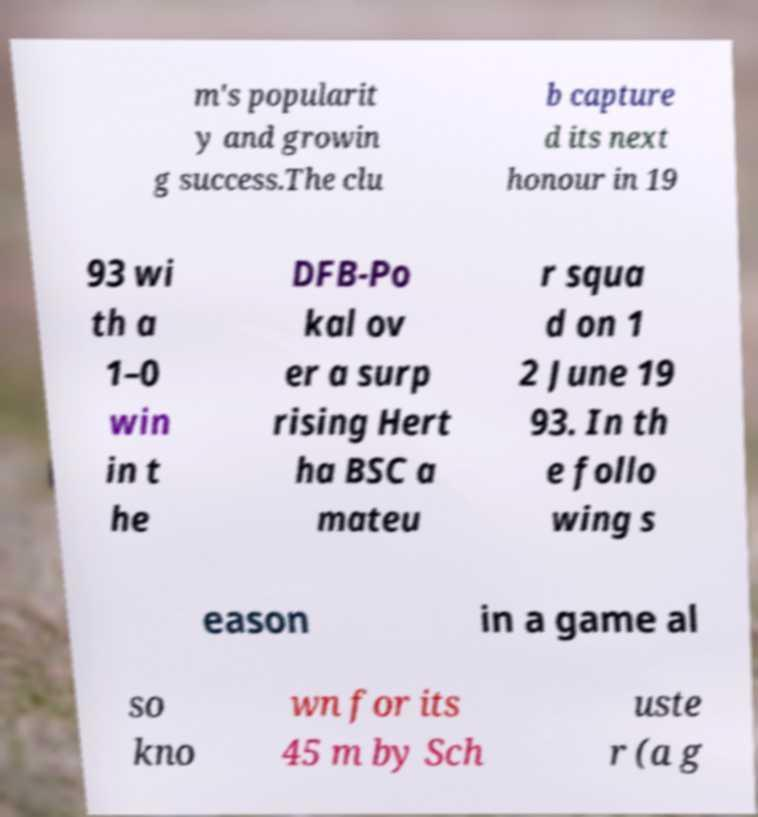Could you extract and type out the text from this image? m's popularit y and growin g success.The clu b capture d its next honour in 19 93 wi th a 1–0 win in t he DFB-Po kal ov er a surp rising Hert ha BSC a mateu r squa d on 1 2 June 19 93. In th e follo wing s eason in a game al so kno wn for its 45 m by Sch uste r (a g 